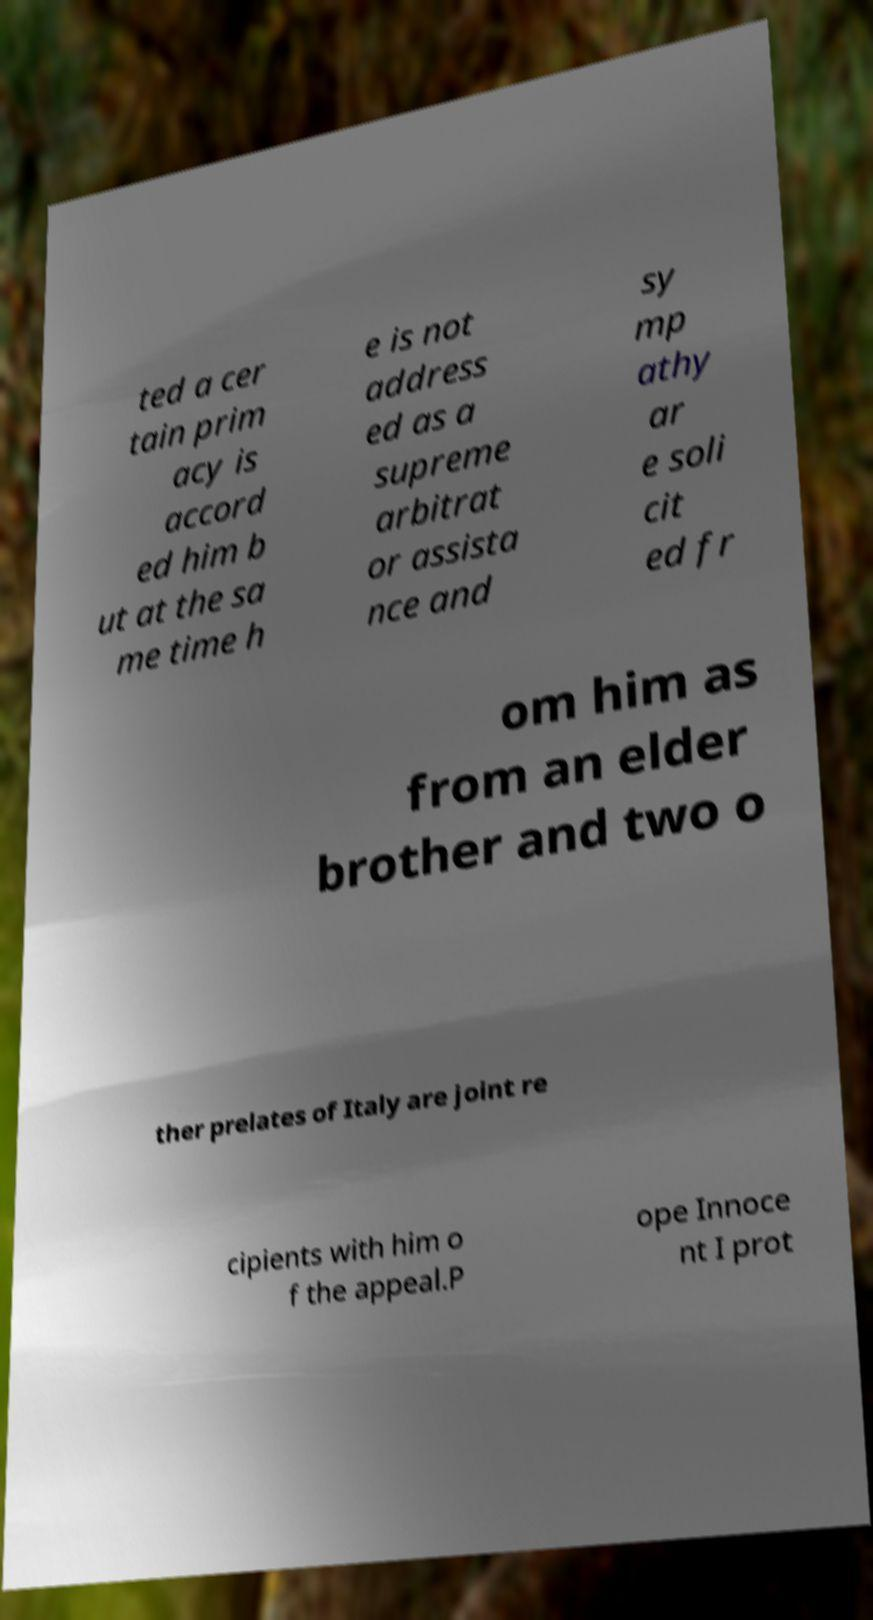There's text embedded in this image that I need extracted. Can you transcribe it verbatim? ted a cer tain prim acy is accord ed him b ut at the sa me time h e is not address ed as a supreme arbitrat or assista nce and sy mp athy ar e soli cit ed fr om him as from an elder brother and two o ther prelates of Italy are joint re cipients with him o f the appeal.P ope Innoce nt I prot 